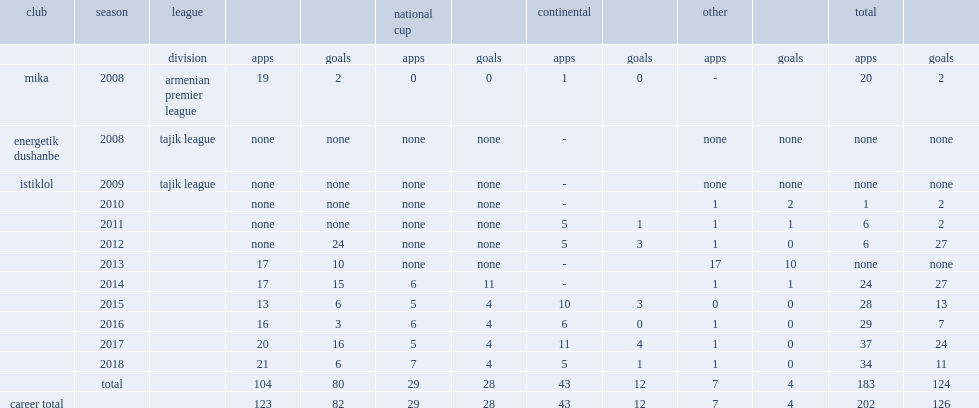Write the full table. {'header': ['club', 'season', 'league', '', '', 'national cup', '', 'continental', '', 'other', '', 'total', ''], 'rows': [['', '', 'division', 'apps', 'goals', 'apps', 'goals', 'apps', 'goals', 'apps', 'goals', 'apps', 'goals'], ['mika', '2008', 'armenian premier league', '19', '2', '0', '0', '1', '0', '-', '', '20', '2'], ['energetik dushanbe', '2008', 'tajik league', 'none', 'none', 'none', 'none', '-', '', 'none', 'none', 'none', 'none'], ['istiklol', '2009', 'tajik league', 'none', 'none', 'none', 'none', '-', '', 'none', 'none', 'none', 'none'], ['', '2010', '', 'none', 'none', 'none', 'none', '-', '', '1', '2', '1', '2'], ['', '2011', '', 'none', 'none', 'none', 'none', '5', '1', '1', '1', '6', '2'], ['', '2012', '', 'none', '24', 'none', 'none', '5', '3', '1', '0', '6', '27'], ['', '2013', '', '17', '10', 'none', 'none', '-', '', '17', '10', 'none', 'none'], ['', '2014', '', '17', '15', '6', '11', '-', '', '1', '1', '24', '27'], ['', '2015', '', '13', '6', '5', '4', '10', '3', '0', '0', '28', '13'], ['', '2016', '', '16', '3', '6', '4', '6', '0', '1', '0', '29', '7'], ['', '2017', '', '20', '16', '5', '4', '11', '4', '1', '0', '37', '24'], ['', '2018', '', '21', '6', '7', '4', '5', '1', '1', '0', '34', '11'], ['', 'total', '', '104', '80', '29', '28', '43', '12', '7', '4', '183', '124'], ['career total', '', '', '123', '82', '29', '28', '43', '12', '7', '4', '202', '126']]} During 2008, which club did vasiev play for, in the armenian premier league? Mika. 